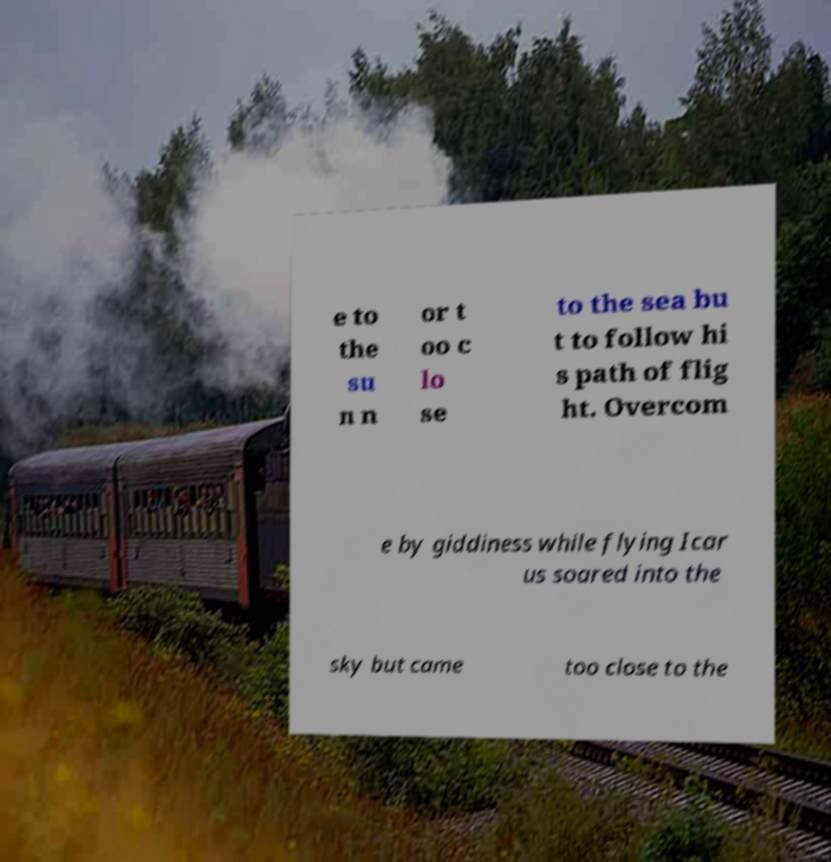Could you assist in decoding the text presented in this image and type it out clearly? e to the su n n or t oo c lo se to the sea bu t to follow hi s path of flig ht. Overcom e by giddiness while flying Icar us soared into the sky but came too close to the 